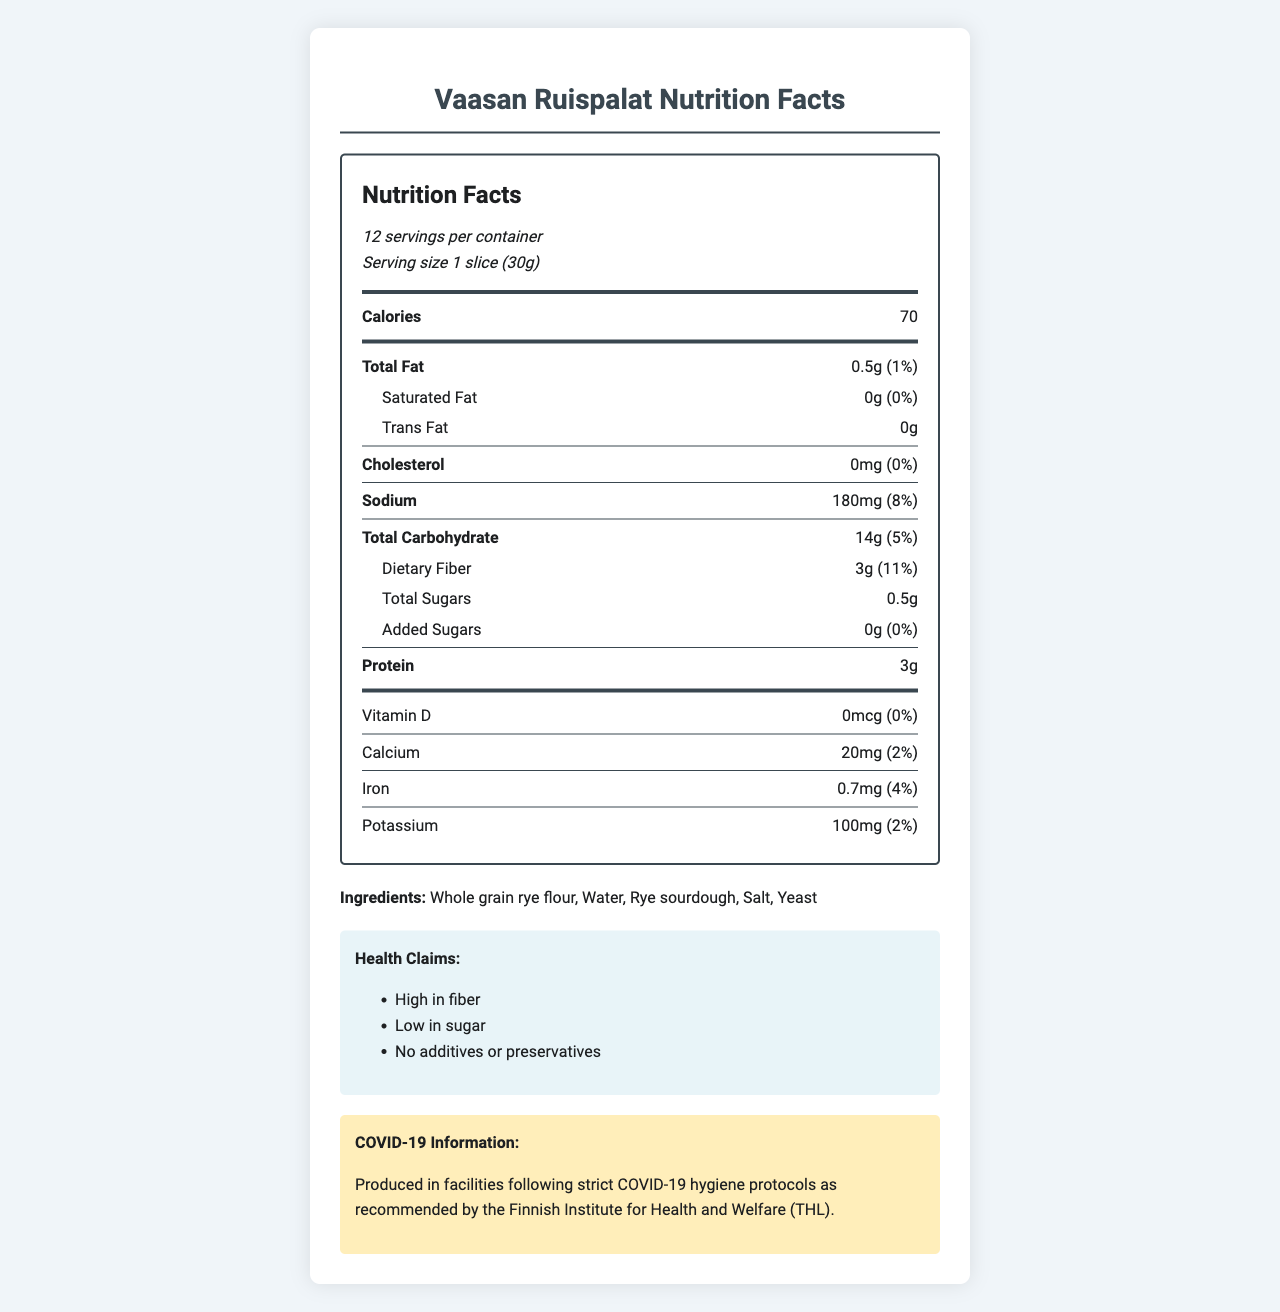what is the serving size of Vaasan Ruispalat? The serving size is listed as "1 slice (30g)" under the serving information.
Answer: 1 slice (30g) how many calories are there per serving? The calories per serving are listed as 70 in the nutrient row for calories.
Answer: 70 how much dietary fiber is in each serving? The dietary fiber content per serving is listed as 3g in the sub-nutrient row under Total Carbohydrate.
Answer: 3g what percentage of the daily value for sodium does one serving provide? The daily value for sodium per serving is listed as 8%.
Answer: 8% what are the main ingredients in Vaasan Ruispalat? The ingredients list includes Whole grain rye flour, Water, Rye sourdough, Salt, and Yeast.
Answer: Whole grain rye flour, Water, Rye sourdough, Salt, Yeast what is the total amount of carbohydrates per serving? The total carbohydrate amount per serving is listed as 14g.
Answer: 14g how much protein is in one slice of Vaasan Ruispalat? There is 3g of protein per serving listed in the nutrient row for protein.
Answer: 3g which of the following nutrients has the highest daily value percentage per serving? A. Iron B. Calcium C. Dietary Fiber D. Potassium The daily value for dietary fiber is 11%, which is higher than Iron (4%), Calcium (2%), and Potassium (2%).
Answer: C. Dietary Fiber how much-added sugar does Vaasan Ruispalat contain per serving? A. 0g B. 0.5g C. 1g D. 3g The amount of added sugar is listed as 0g per serving.
Answer: A. 0g is the product gluten-free? The allergen information states that the product contains rye, which has gluten.
Answer: No does the product contain any preservatives? The health claims state that the product has no additives or preservatives.
Answer: No describe the main health benefits of eating this rye bread. The document lists health claims that include "High in fiber" and "Low in sugar."
Answer: High in fiber and low in sugar are there any COVID-19 safety measures mentioned in the document? The pandemic-related info mentions that the product is produced in facilities following strict COVID-19 hygiene protocols as recommended by the Finnish Institute for Health and Welfare (THL).
Answer: Yes can you determine how much vitamin C the bread contains? The document does not provide any information about vitamin C content.
Answer: Not enough information what percentage of the daily value for calcium does one serving cover? The daily value for calcium per serving is listed as 2%.
Answer: 2% how many servings are in one container of Vaasan Ruispalat? The serving information states there are 12 servings per container.
Answer: 12 how much fat is in each serving? The total fat per serving is listed as 0.5g.
Answer: 0.5g summarize the nutrition information provided for Vaasan Ruispalat. The document highlights the nutritional content, ingredients, health benefits, and certifications of the product while mentioning COVID-19 related safety measures.
Answer: Vaasan Ruispalat is a rye bread from Finland that offers high fiber (3g per serving, 11% DV) and low sugar (0.5g total sugars, 0g added sugars). Each serving (1 slice, 30g) contains 70 calories, 0.5g total fat, 180mg sodium (8% DV), 14g carbohydrates (5% DV), and 3g protein. It contains essential minerals like calcium (20mg, 2% DV), iron (0.7mg, 4% DV), and potassium (100mg, 2% DV). The bread is made from whole grain rye flour, water, rye sourdough, salt, and yeast, and contains gluten. The product is certified with the Heart Symbol and Key Flag Symbol and is produced under COVID-19 hygiene protocols. 